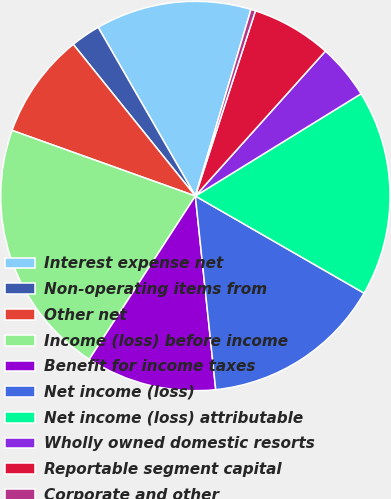<chart> <loc_0><loc_0><loc_500><loc_500><pie_chart><fcel>Interest expense net<fcel>Non-operating items from<fcel>Other net<fcel>Income (loss) before income<fcel>Benefit for income taxes<fcel>Net income (loss)<fcel>Net income (loss) attributable<fcel>Wholly owned domestic resorts<fcel>Reportable segment capital<fcel>Corporate and other<nl><fcel>12.93%<fcel>2.47%<fcel>8.74%<fcel>21.3%<fcel>10.84%<fcel>15.02%<fcel>17.11%<fcel>4.56%<fcel>6.65%<fcel>0.38%<nl></chart> 